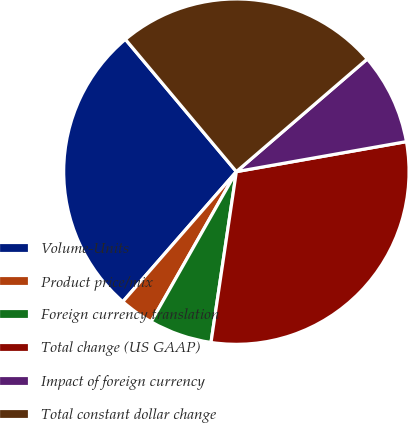<chart> <loc_0><loc_0><loc_500><loc_500><pie_chart><fcel>Volume-Units<fcel>Product price/mix<fcel>Foreign currency translation<fcel>Total change (US GAAP)<fcel>Impact of foreign currency<fcel>Total constant dollar change<nl><fcel>27.47%<fcel>3.21%<fcel>5.87%<fcel>30.13%<fcel>8.53%<fcel>24.8%<nl></chart> 